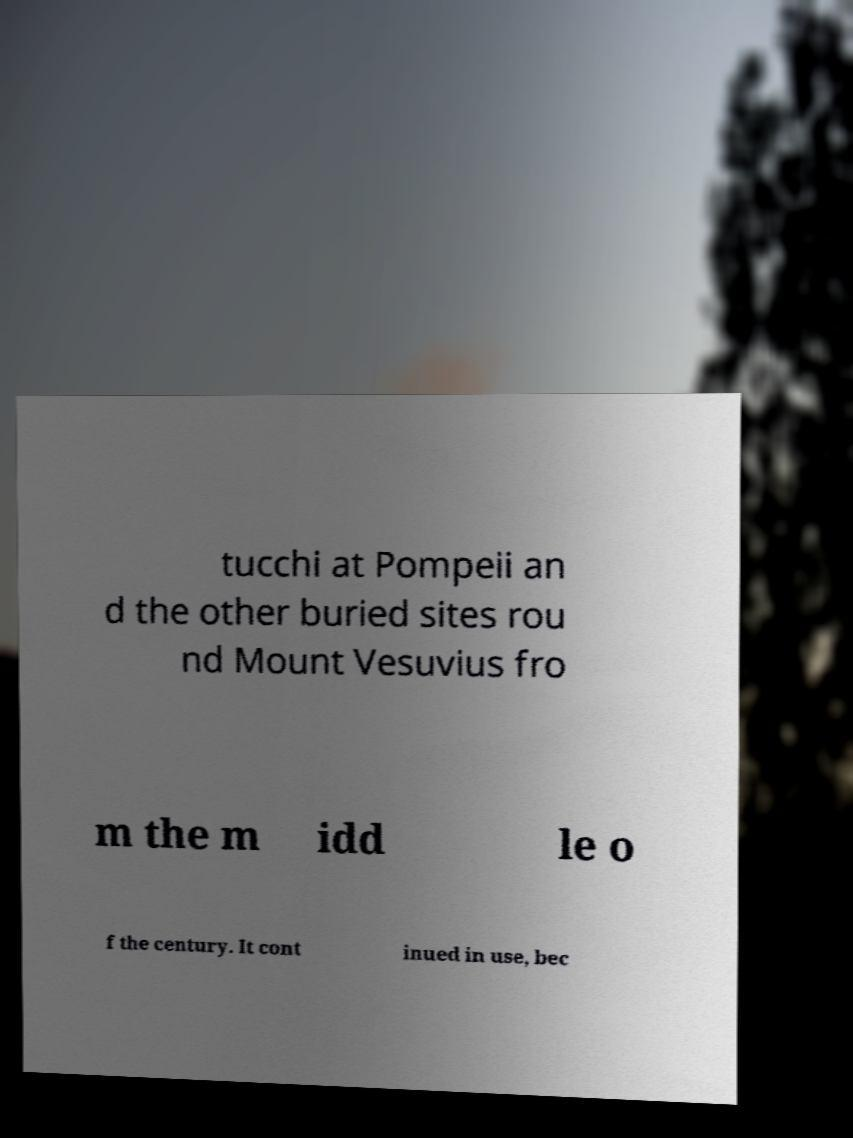Can you read and provide the text displayed in the image?This photo seems to have some interesting text. Can you extract and type it out for me? tucchi at Pompeii an d the other buried sites rou nd Mount Vesuvius fro m the m idd le o f the century. It cont inued in use, bec 